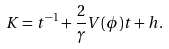Convert formula to latex. <formula><loc_0><loc_0><loc_500><loc_500>K = t ^ { - 1 } + \frac { 2 } { \gamma } V ( \phi ) t + h .</formula> 